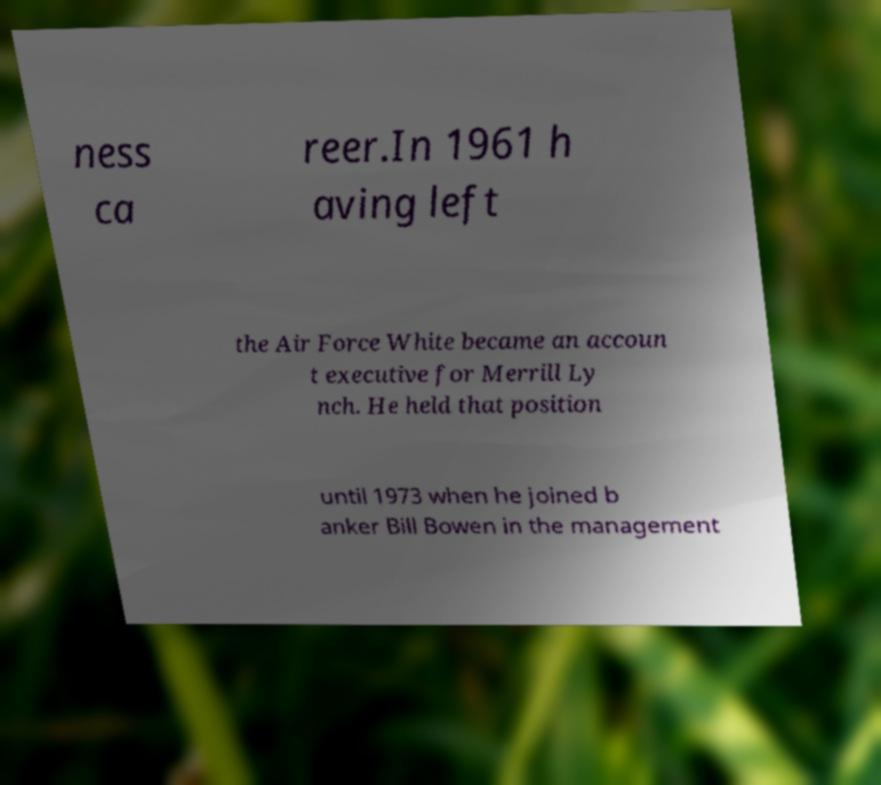Can you accurately transcribe the text from the provided image for me? ness ca reer.In 1961 h aving left the Air Force White became an accoun t executive for Merrill Ly nch. He held that position until 1973 when he joined b anker Bill Bowen in the management 